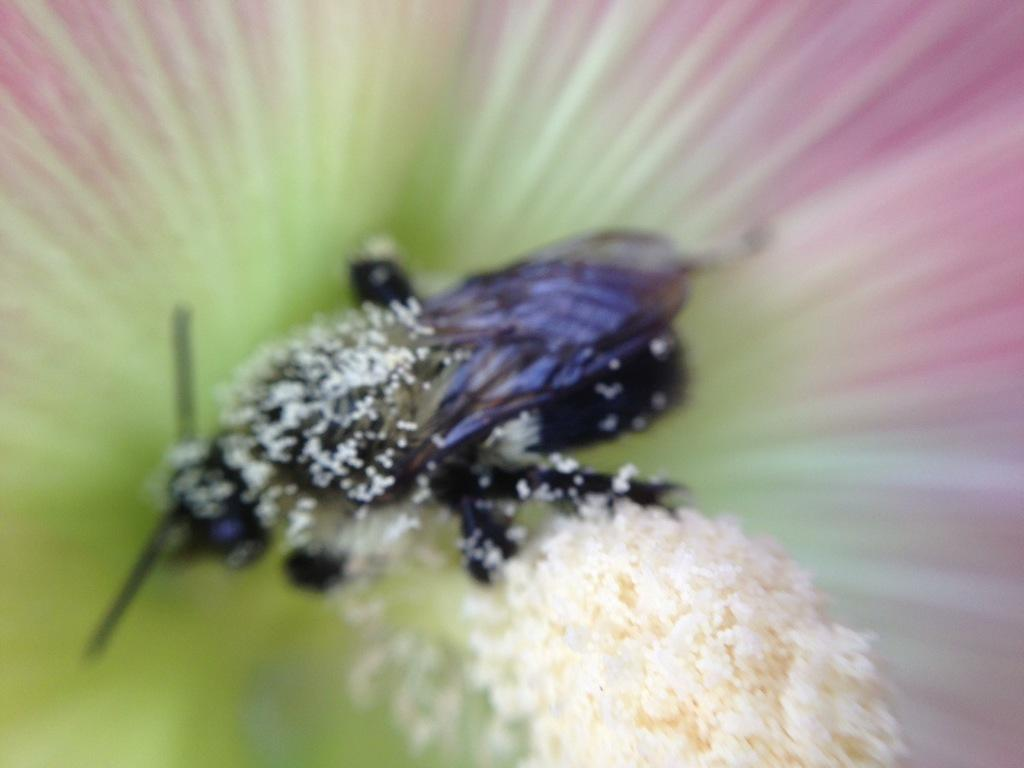What is the main subject in the middle of the picture? There is an insect in the middle of the picture. Can you describe the color of the insect? The insect is black in color. What can be seen at the bottom of the picture? There is a flower in the bottom of the picture. How would you describe the background of the image? The background of the image is blurred. How many passengers are visible in the image? There are no passengers present in the image; it features an insect and a flower. What type of ink is being used to draw the insect in the image? The image is a photograph, not a drawing, so there is no ink used. 